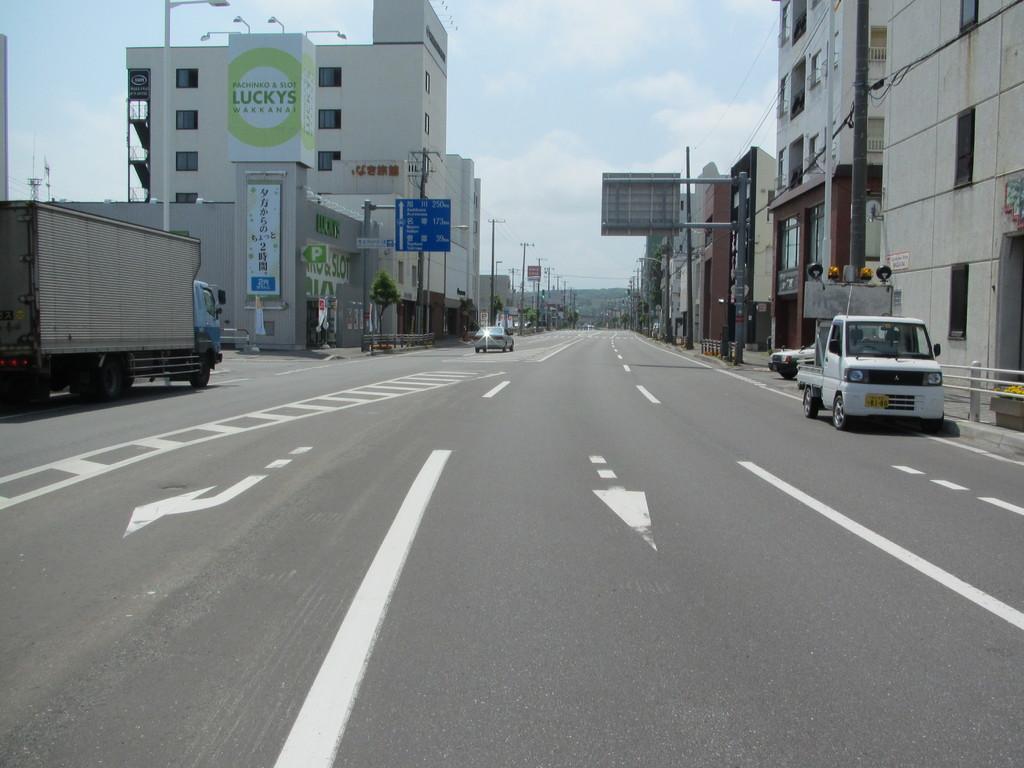Can you describe this image briefly? In the image we can see there are vehicles on the road. We can even see there are buildings and these are the windows of the buildings. Here we can see light poles, electric poles and electric wires. Here we can see boards and text on the boards. Here we can see the barrier, plant, hill and the sky. 